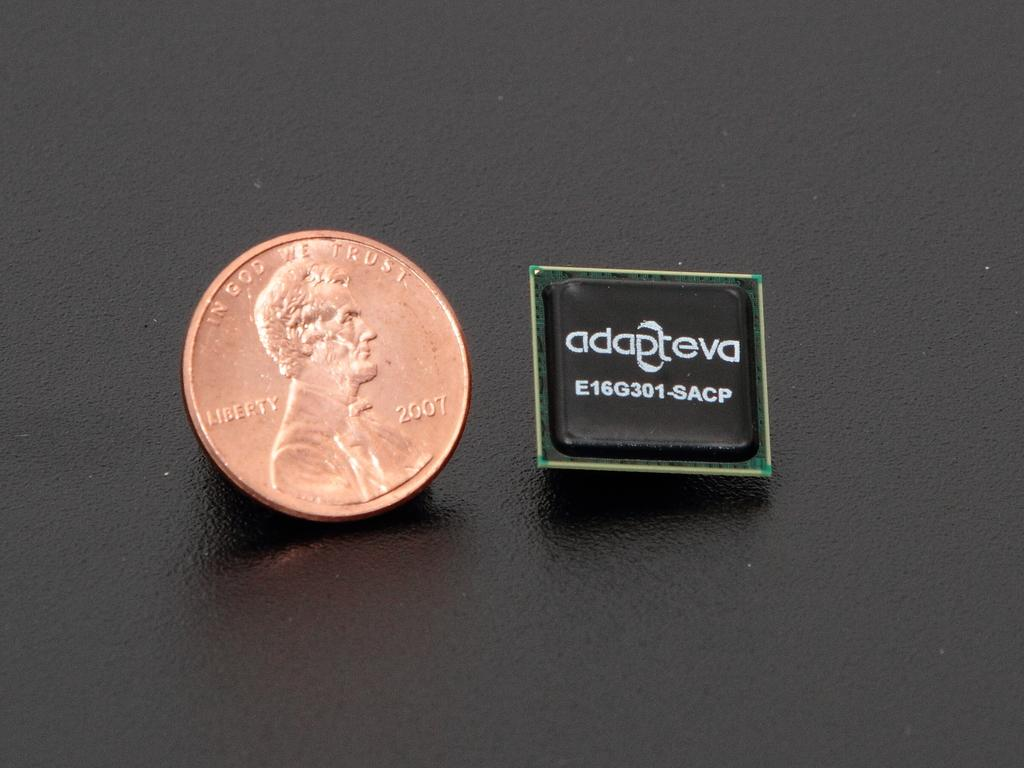<image>
Create a compact narrative representing the image presented. Copper coin saying In God We Trust next to a square object. 